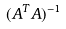Convert formula to latex. <formula><loc_0><loc_0><loc_500><loc_500>( A ^ { T } A ) ^ { - 1 }</formula> 